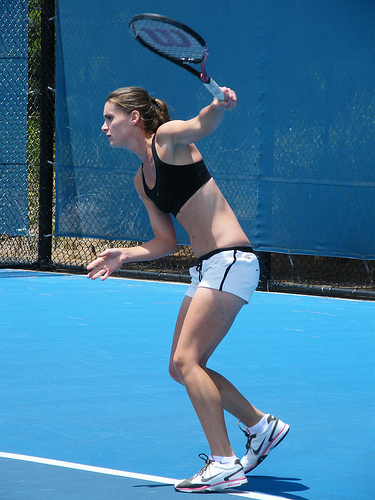The person is playing what? The person in the image is actively engaged in playing tennis, as indicated by her pose and equipment. 